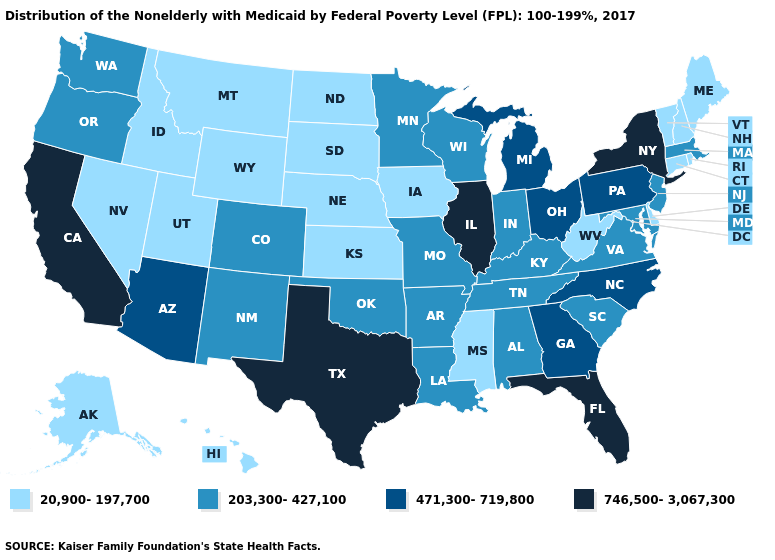What is the value of Tennessee?
Answer briefly. 203,300-427,100. Name the states that have a value in the range 203,300-427,100?
Concise answer only. Alabama, Arkansas, Colorado, Indiana, Kentucky, Louisiana, Maryland, Massachusetts, Minnesota, Missouri, New Jersey, New Mexico, Oklahoma, Oregon, South Carolina, Tennessee, Virginia, Washington, Wisconsin. Does Maine have the lowest value in the USA?
Keep it brief. Yes. Name the states that have a value in the range 471,300-719,800?
Write a very short answer. Arizona, Georgia, Michigan, North Carolina, Ohio, Pennsylvania. What is the highest value in the USA?
Give a very brief answer. 746,500-3,067,300. Does Delaware have a lower value than Idaho?
Give a very brief answer. No. What is the value of Kentucky?
Give a very brief answer. 203,300-427,100. What is the value of Georgia?
Quick response, please. 471,300-719,800. Name the states that have a value in the range 20,900-197,700?
Short answer required. Alaska, Connecticut, Delaware, Hawaii, Idaho, Iowa, Kansas, Maine, Mississippi, Montana, Nebraska, Nevada, New Hampshire, North Dakota, Rhode Island, South Dakota, Utah, Vermont, West Virginia, Wyoming. Which states have the lowest value in the USA?
Keep it brief. Alaska, Connecticut, Delaware, Hawaii, Idaho, Iowa, Kansas, Maine, Mississippi, Montana, Nebraska, Nevada, New Hampshire, North Dakota, Rhode Island, South Dakota, Utah, Vermont, West Virginia, Wyoming. What is the value of Kentucky?
Keep it brief. 203,300-427,100. Does the map have missing data?
Concise answer only. No. What is the value of Minnesota?
Keep it brief. 203,300-427,100. What is the lowest value in the MidWest?
Give a very brief answer. 20,900-197,700. What is the value of Nebraska?
Write a very short answer. 20,900-197,700. 